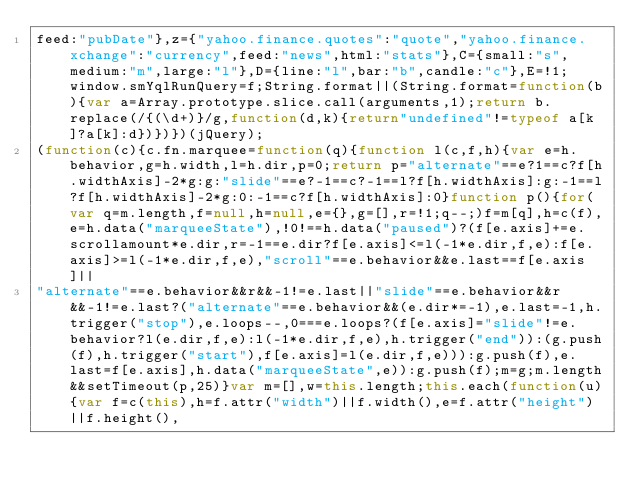<code> <loc_0><loc_0><loc_500><loc_500><_JavaScript_>feed:"pubDate"},z={"yahoo.finance.quotes":"quote","yahoo.finance.xchange":"currency",feed:"news",html:"stats"},C={small:"s",medium:"m",large:"l"},D={line:"l",bar:"b",candle:"c"},E=!1;window.smYqlRunQuery=f;String.format||(String.format=function(b){var a=Array.prototype.slice.call(arguments,1);return b.replace(/{(\d+)}/g,function(d,k){return"undefined"!=typeof a[k]?a[k]:d})})})(jQuery);
(function(c){c.fn.marquee=function(q){function l(c,f,h){var e=h.behavior,g=h.width,l=h.dir,p=0;return p="alternate"==e?1==c?f[h.widthAxis]-2*g:g:"slide"==e?-1==c?-1==l?f[h.widthAxis]:g:-1==l?f[h.widthAxis]-2*g:0:-1==c?f[h.widthAxis]:0}function p(){for(var q=m.length,f=null,h=null,e={},g=[],r=!1;q--;)f=m[q],h=c(f),e=h.data("marqueeState"),!0!==h.data("paused")?(f[e.axis]+=e.scrollamount*e.dir,r=-1==e.dir?f[e.axis]<=l(-1*e.dir,f,e):f[e.axis]>=l(-1*e.dir,f,e),"scroll"==e.behavior&&e.last==f[e.axis]||
"alternate"==e.behavior&&r&&-1!=e.last||"slide"==e.behavior&&r&&-1!=e.last?("alternate"==e.behavior&&(e.dir*=-1),e.last=-1,h.trigger("stop"),e.loops--,0===e.loops?(f[e.axis]="slide"!=e.behavior?l(e.dir,f,e):l(-1*e.dir,f,e),h.trigger("end")):(g.push(f),h.trigger("start"),f[e.axis]=l(e.dir,f,e))):g.push(f),e.last=f[e.axis],h.data("marqueeState",e)):g.push(f);m=g;m.length&&setTimeout(p,25)}var m=[],w=this.length;this.each(function(u){var f=c(this),h=f.attr("width")||f.width(),e=f.attr("height")||f.height(),</code> 